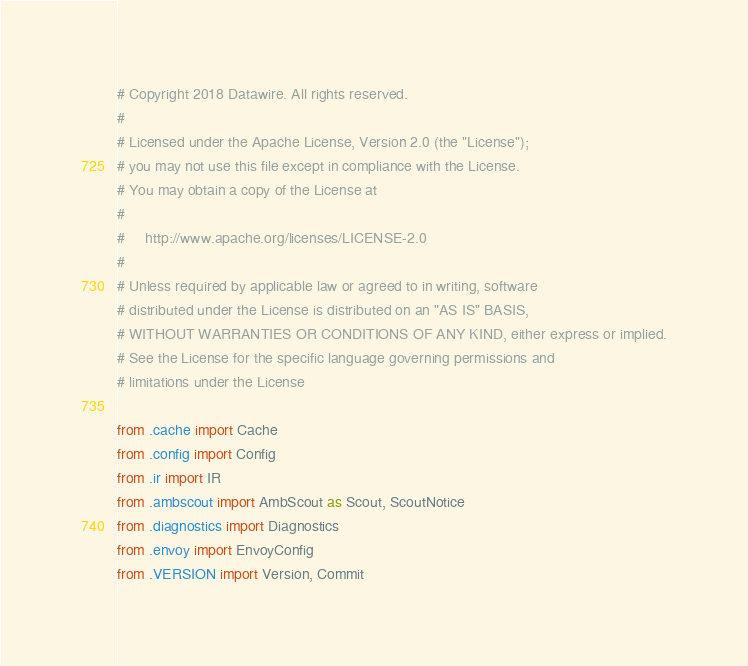Convert code to text. <code><loc_0><loc_0><loc_500><loc_500><_Python_># Copyright 2018 Datawire. All rights reserved.
#
# Licensed under the Apache License, Version 2.0 (the "License");
# you may not use this file except in compliance with the License.
# You may obtain a copy of the License at
#
#     http://www.apache.org/licenses/LICENSE-2.0
#
# Unless required by applicable law or agreed to in writing, software
# distributed under the License is distributed on an "AS IS" BASIS,
# WITHOUT WARRANTIES OR CONDITIONS OF ANY KIND, either express or implied.
# See the License for the specific language governing permissions and
# limitations under the License

from .cache import Cache
from .config import Config
from .ir import IR
from .ambscout import AmbScout as Scout, ScoutNotice
from .diagnostics import Diagnostics
from .envoy import EnvoyConfig
from .VERSION import Version, Commit
</code> 